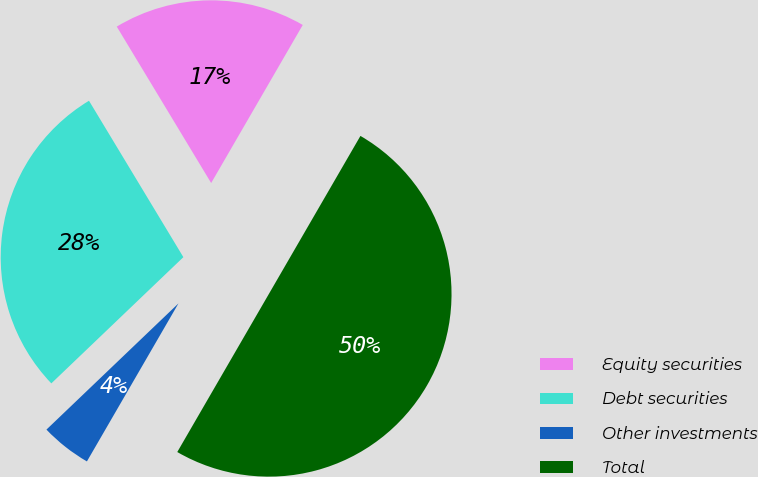Convert chart. <chart><loc_0><loc_0><loc_500><loc_500><pie_chart><fcel>Equity securities<fcel>Debt securities<fcel>Other investments<fcel>Total<nl><fcel>17.0%<fcel>28.5%<fcel>4.5%<fcel>50.0%<nl></chart> 